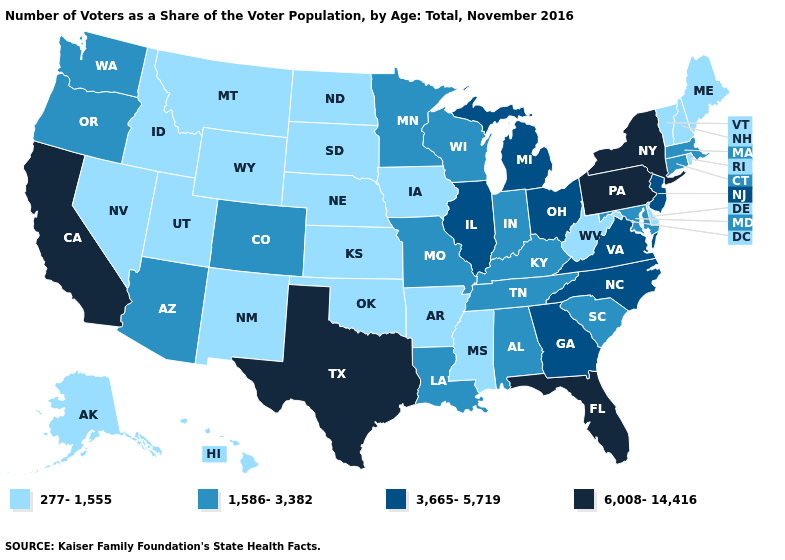Name the states that have a value in the range 1,586-3,382?
Answer briefly. Alabama, Arizona, Colorado, Connecticut, Indiana, Kentucky, Louisiana, Maryland, Massachusetts, Minnesota, Missouri, Oregon, South Carolina, Tennessee, Washington, Wisconsin. What is the value of Oregon?
Concise answer only. 1,586-3,382. Among the states that border Maryland , does Virginia have the lowest value?
Short answer required. No. Name the states that have a value in the range 277-1,555?
Short answer required. Alaska, Arkansas, Delaware, Hawaii, Idaho, Iowa, Kansas, Maine, Mississippi, Montana, Nebraska, Nevada, New Hampshire, New Mexico, North Dakota, Oklahoma, Rhode Island, South Dakota, Utah, Vermont, West Virginia, Wyoming. Name the states that have a value in the range 277-1,555?
Be succinct. Alaska, Arkansas, Delaware, Hawaii, Idaho, Iowa, Kansas, Maine, Mississippi, Montana, Nebraska, Nevada, New Hampshire, New Mexico, North Dakota, Oklahoma, Rhode Island, South Dakota, Utah, Vermont, West Virginia, Wyoming. What is the lowest value in the USA?
Short answer required. 277-1,555. Name the states that have a value in the range 277-1,555?
Keep it brief. Alaska, Arkansas, Delaware, Hawaii, Idaho, Iowa, Kansas, Maine, Mississippi, Montana, Nebraska, Nevada, New Hampshire, New Mexico, North Dakota, Oklahoma, Rhode Island, South Dakota, Utah, Vermont, West Virginia, Wyoming. Among the states that border Massachusetts , which have the highest value?
Short answer required. New York. Is the legend a continuous bar?
Short answer required. No. What is the value of South Dakota?
Answer briefly. 277-1,555. Does Michigan have the highest value in the MidWest?
Short answer required. Yes. Does South Dakota have the lowest value in the MidWest?
Answer briefly. Yes. What is the value of Maine?
Answer briefly. 277-1,555. Does Utah have the lowest value in the USA?
Answer briefly. Yes. What is the value of Michigan?
Answer briefly. 3,665-5,719. 